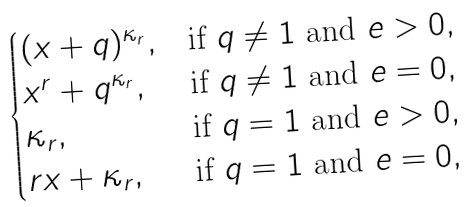Convert formula to latex. <formula><loc_0><loc_0><loc_500><loc_500>\begin{cases} ( x + q ) ^ { \kappa _ { r } } , & \text {if $q\neq 1$ and $e>0$} , \\ x ^ { r } + q ^ { \kappa _ { r } } , & \text {if $q\ne1$ and $e=0$} , \\ \kappa _ { r } , & \text {if $q=1$ and $e>0$} , \\ r x + \kappa _ { r } , & \text {if $q=1$ and $e=0$} , \end{cases}</formula> 